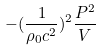<formula> <loc_0><loc_0><loc_500><loc_500>- ( \frac { 1 } { \rho _ { 0 } c ^ { 2 } } ) ^ { 2 } \frac { P ^ { 2 } } { V }</formula> 